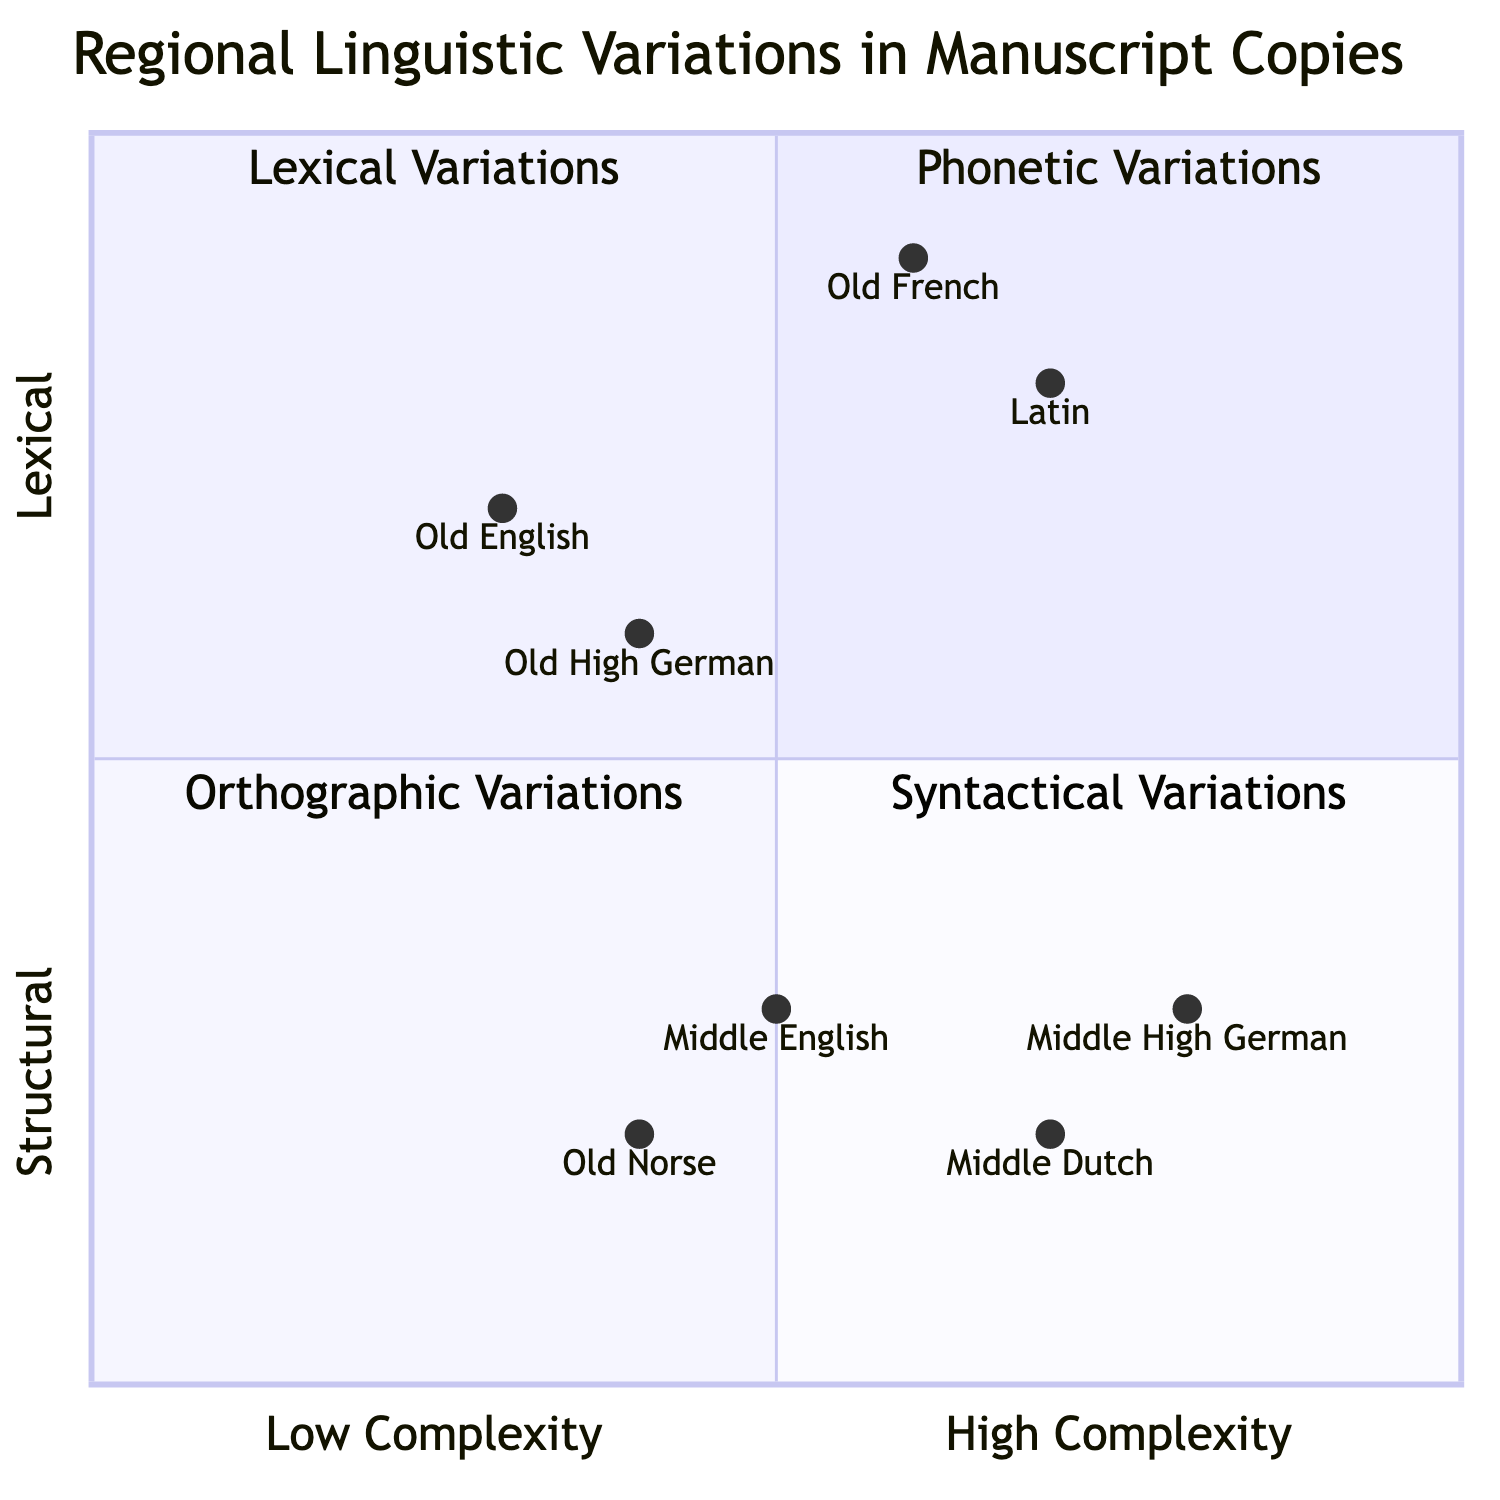What is the title of Quadrant 1? The title of Quadrant 1 is directly labeled in the diagram as "Phonetic Variations."
Answer: Phonetic Variations Which element has the highest complexity in the chart? The complexity is measured on the x-axis, and the element with the highest score of 0.8 is "Latin."
Answer: Latin How many elements are in Quadrant 2? Quadrant 2, labeled as "Lexical Variations," contains two elements: "Latin" and "Old French." Thus, there are a total of 2 elements.
Answer: 2 What syntactical variation is least complex? Looking at Quadrant 4, "Middle Dutch" has a complexity score of 0.7, which is less than the other element in that quadrant.
Answer: Middle Dutch Which variation uses runic script? In Quadrant 3, "Old Norse" is described as using runic versus Latin script; therefore, it is the one that employs runic script.
Answer: Old Norse What is the combination of complexity and structure for "Old High German"? The coordinates for "Old High German" are [0.4, 0.6], indicating a complexity of 0.4 and a structure level of 0.6.
Answer: [0.4, 0.6] Which quadrant contains variations in spelling? Quadrant 3, titled "Orthographic Variations," contains the variations in spelling indicated in the element "Middle English."
Answer: Orthographic Variations What is the relationship between "Latin" and "Old French" concerning their complexity? "Latin" has a complexity score of 0.7, while "Old French" has a score of 0.6, indicating that "Latin" is more complex than "Old French."
Answer: Latin is more complex than Old French Which element is located in the lowest structural position? The element "Old Norse" in Quadrant 3 has a structure score of 0.2, which is the lowest among all elements.
Answer: Old Norse 